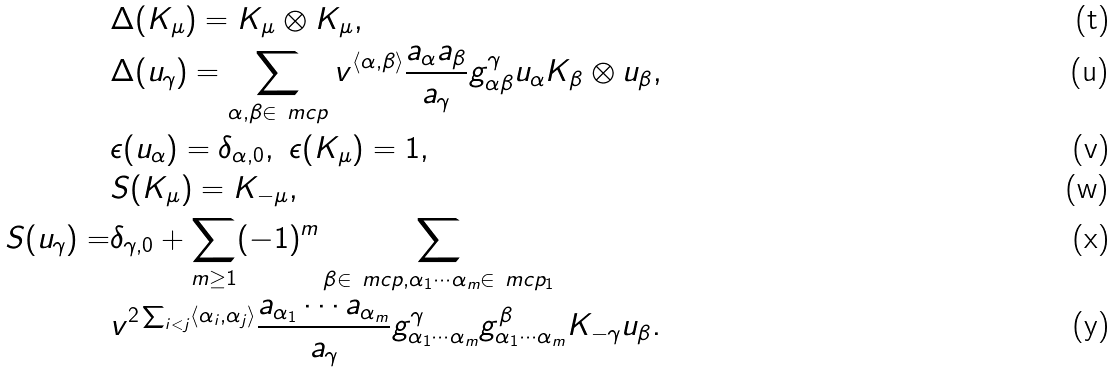Convert formula to latex. <formula><loc_0><loc_0><loc_500><loc_500>& \Delta ( K _ { \mu } ) = K _ { \mu } \otimes K _ { \mu } , \\ & \Delta ( u _ { \gamma } ) = \sum _ { \alpha , \beta \in \ m c p } v ^ { \langle \alpha , \beta \rangle } \frac { a _ { \alpha } a _ { \beta } } { a _ { \gamma } } g ^ { \gamma } _ { \alpha \beta } u _ { \alpha } K _ { \beta } \otimes u _ { \beta } , \\ & \epsilon ( u _ { \alpha } ) = \delta _ { \alpha , 0 } , \ \epsilon ( K _ { \mu } ) = 1 , \\ & S ( K _ { \mu } ) = K _ { - \mu } , \\ S ( u _ { \gamma } ) = & \delta _ { \gamma , 0 } + \sum _ { m \geq 1 } ( - 1 ) ^ { m } \sum _ { \beta \in \ m c p , \alpha _ { 1 } \cdots \alpha _ { m } \in \ m c p _ { 1 } } \\ & v ^ { 2 \sum _ { i < j } \langle \alpha _ { i } , \alpha _ { j } \rangle } \frac { a _ { \alpha _ { 1 } } \cdots a _ { \alpha _ { m } } } { a _ { \gamma } } g ^ { \gamma } _ { \alpha _ { 1 } \cdots \alpha _ { m } } g ^ { \beta } _ { \alpha _ { 1 } \cdots \alpha _ { m } } K _ { - \gamma } u _ { \beta } .</formula> 